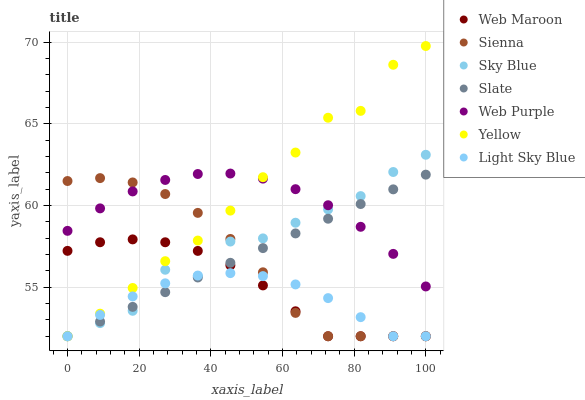Does Light Sky Blue have the minimum area under the curve?
Answer yes or no. Yes. Does Yellow have the maximum area under the curve?
Answer yes or no. Yes. Does Web Maroon have the minimum area under the curve?
Answer yes or no. No. Does Web Maroon have the maximum area under the curve?
Answer yes or no. No. Is Slate the smoothest?
Answer yes or no. Yes. Is Sky Blue the roughest?
Answer yes or no. Yes. Is Web Maroon the smoothest?
Answer yes or no. No. Is Web Maroon the roughest?
Answer yes or no. No. Does Slate have the lowest value?
Answer yes or no. Yes. Does Web Purple have the lowest value?
Answer yes or no. No. Does Yellow have the highest value?
Answer yes or no. Yes. Does Web Maroon have the highest value?
Answer yes or no. No. Is Light Sky Blue less than Web Purple?
Answer yes or no. Yes. Is Web Purple greater than Light Sky Blue?
Answer yes or no. Yes. Does Yellow intersect Web Purple?
Answer yes or no. Yes. Is Yellow less than Web Purple?
Answer yes or no. No. Is Yellow greater than Web Purple?
Answer yes or no. No. Does Light Sky Blue intersect Web Purple?
Answer yes or no. No. 